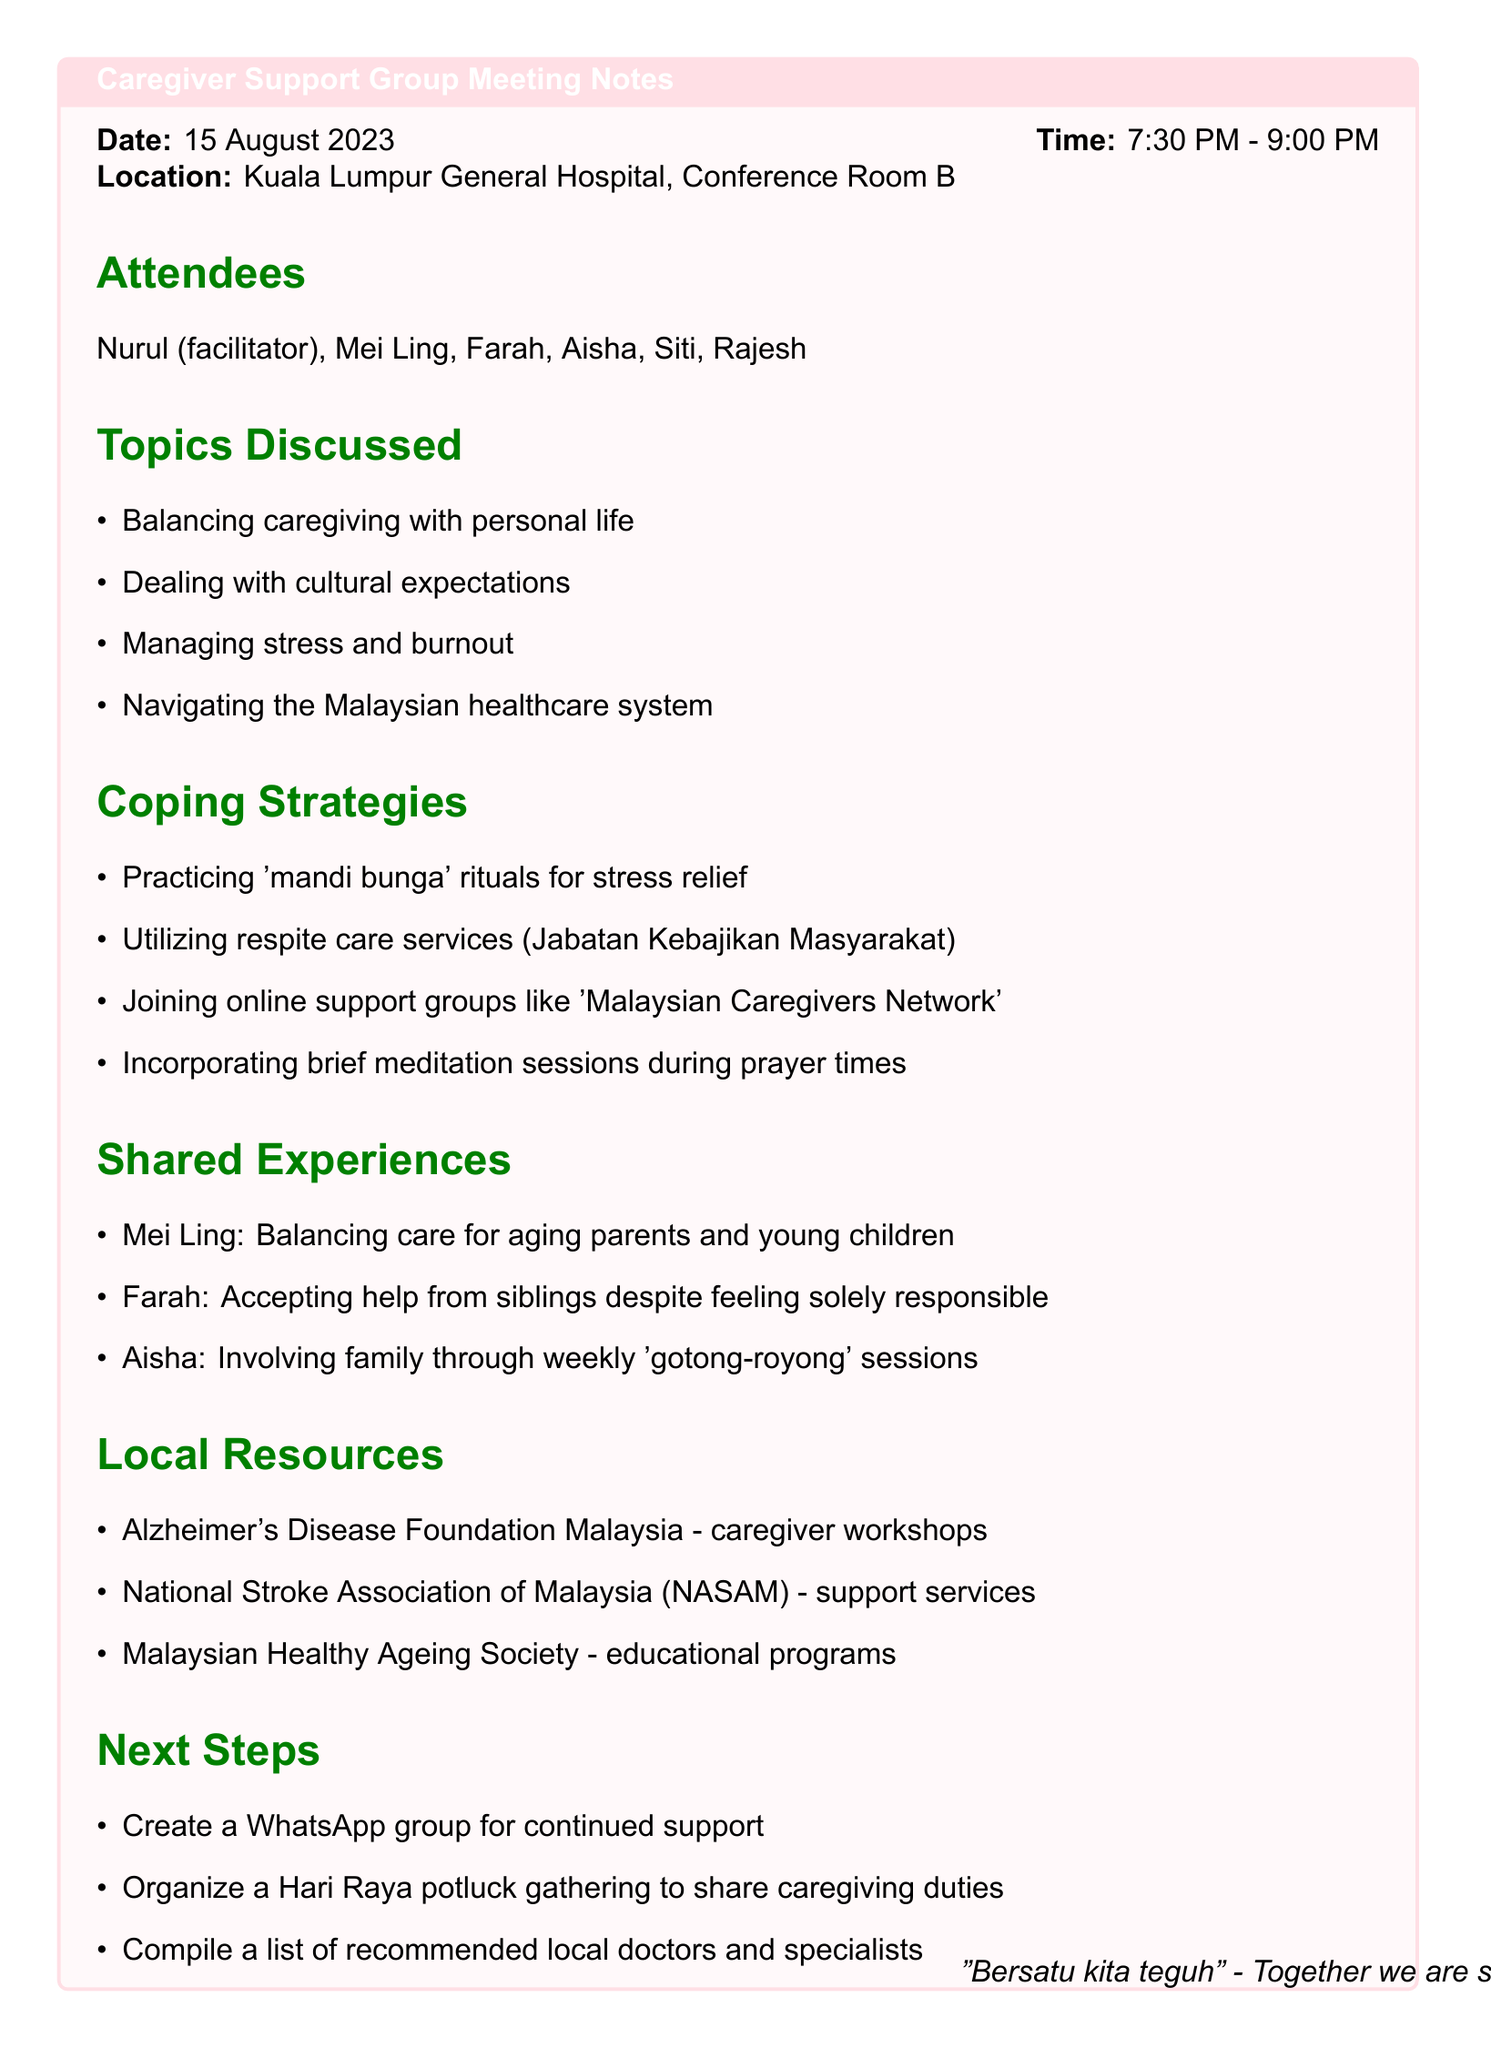What is the date of the meeting? The date of the meeting is explicitly mentioned in the document.
Answer: 15 August 2023 Who facilitated the meeting? The document lists attendees and specifies one as the facilitator.
Answer: Nurul What time did the meeting start? The start time is provided in the meeting details section.
Answer: 7:30 PM Which coping strategy involves cultural practices? The coping strategies include various methods for managing stress, highlighting cultural practices.
Answer: 'mandi bunga' What common challenge did Mei Ling share? Shared experiences include personal challenges faced by attendees, including Mei Ling's.
Answer: Balancing care for aging parents and young children What local resource offers caregiver workshops? The document lists local resources available for caregivers, including workshops.
Answer: Alzheimer's Disease Foundation Malaysia How many attendees were present at the meeting? The list of attendees in the document specifies the number of individuals present.
Answer: 6 What is one next step mentioned following the meeting? The next steps section highlights actions the group plans to take.
Answer: Create a WhatsApp group for continued support Which topic focused on personal well-being? The document discusses various topics, including one related to caregiver stress.
Answer: Managing stress and burnout 